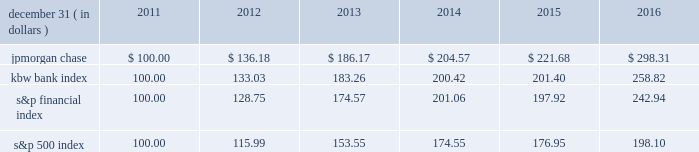Jpmorgan chase & co./2016 annual report 35 five-year stock performance the table and graph compare the five-year cumulative total return for jpmorgan chase & co .
( 201cjpmorgan chase 201d or the 201cfirm 201d ) common stock with the cumulative return of the s&p 500 index , the kbw bank index and the s&p financial index .
The s&p 500 index is a commonly referenced united states of america ( 201cu.s . 201d ) equity benchmark consisting of leading companies from different economic sectors .
The kbw bank index seeks to reflect the performance of banks and thrifts that are publicly traded in the u.s .
And is composed of leading national money center and regional banks and thrifts .
The s&p financial index is an index of financial companies , all of which are components of the s&p 500 .
The firm is a component of all three industry indices .
The table and graph assume simultaneous investments of $ 100 on december 31 , 2011 , in jpmorgan chase common stock and in each of the above indices .
The comparison assumes that all dividends are reinvested .
December 31 , ( in dollars ) 2011 2012 2013 2014 2015 2016 .
December 31 , ( in dollars ) .
What was the 5 year return of jpmorgan chase's stock? 
Computations: ((298.31 - 100) / 100)
Answer: 1.9831. 